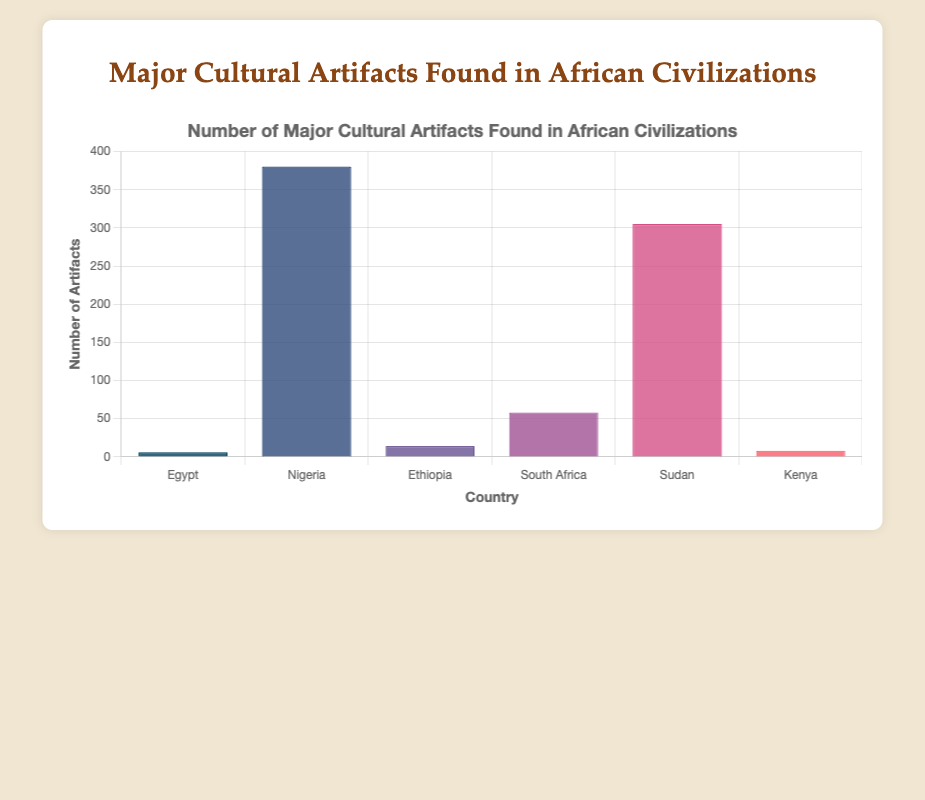What is the total number of artifacts found in Egypt? Egypt has artifacts including Tutankhamun's Mask (1), Rosetta Stone (1), Nefertiti Bust (1), and Pyramid Texts (3). Summing these quantities gives 1+1+1+3 = 6.
Answer: 6 Which country has the highest number of major cultural artifacts? Sudan has the highest count with artifacts like Nubian Pyramids (255), Kushite Statues (20), and Meroitic Scripts (30). Summing the numbers results in 255+20+30 = 305. Other countries have lower totals.
Answer: Sudan How many more artifacts does Nigeria have compared to Egypt? Nigeria's artifacts include Benin Bronzes (200), Ife Terracottas (80), and Nok Figurines (100), summing to 380. Egypt's total is 6. The difference is 380 - 6 = 374.
Answer: 374 What is the average number of artifacts found per country? Summing totals of each country ([6, 380, 14, 58, 305, 8]) gives 6 + 380 + 14 + 58 + 305 + 8 = 771. Dividing by the number of countries (6) gives 771 / 6 = 128.5.
Answer: 128.5 Which country has the tallest bar in the chart, and what does it represent? The tallest bar in the chart represents Sudan, indicating the highest number of major cultural artifacts discovered, which is 305.
Answer: Sudan How do the number of artifacts found in Kenya and Ethiopia compare? Kenya has 1 (Turkana Boy) + 5 (Swahili Ruins of Gedi) + 2 (Lamu Old Town) = 8 artifacts. Ethiopia has 1 (Axum Obelisk) + 11 (Lalibela Churches) + 2 (Kebra Nagast Manuscript) = 14 artifacts. Ethiopia has 14 - 8 = 6 more artifacts than Kenya.
Answer: Ethiopia has 6 more artifacts than Kenya What is the sum of artifacts found in South Africa and Ethiopia? South Africa has 1 (Mapungubwe Gold Rhinoceros) + 50 (Blombos Cave Engravings) + 7 (Lydenburg Heads) = 58. Ethiopia has 14 artifacts. The total is 58 + 14 = 72.
Answer: 72 Identify the color representing the number of artifacts in Egypt. The bar representing Egypt is colored in the first shade from the left, which is generally dark blue in the provided palette for readability.
Answer: dark blue Is the number of artifacts found in Nigeria greater than those found in all other countries combined (excluding Nigeria)? Summing artifacts found in Egypt (6), Ethiopia (14), South Africa (58), Sudan (305), and Kenya (8) gives 6 + 14 + 58 + 305 + 8 = 391. Nigeria has 380 artifacts. Since 380 < 391, Nigeria does not have more artifacts than all other countries combined.
Answer: No What visual pattern can be observed concerning the number of artifacts across the countries? The visual pattern shows that Sudan has the highest bar, representing the highest number of artifacts, followed by Nigeria with a significant number. Egypt and Kenya have the shortest bars, indicating the lowest numbers.
Answer: Sudan with the highest, Egypt and Kenya with the lowest 